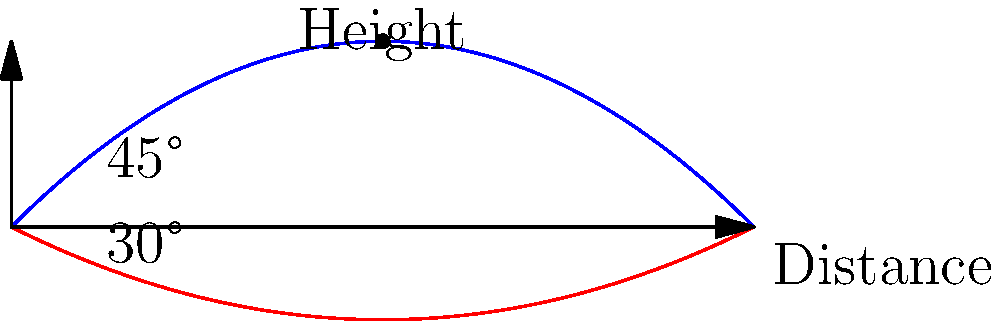As a football coach, you're teaching your players about the optimal angle for a long-distance kick. The graph shows two trajectories: one for a 45° kick (blue) and one for a 30° kick (red). Assuming no air resistance and constant initial velocity, which angle produces the maximum distance, and why? To determine the optimal angle for maximum distance, let's analyze the situation step-by-step:

1) In ideal conditions (no air resistance), the trajectory of a projectile follows a parabolic path.

2) The range (R) of a projectile is given by the formula:
   $$R = \frac{v^2 \sin(2\theta)}{g}$$
   where $v$ is the initial velocity, $\theta$ is the launch angle, and $g$ is the acceleration due to gravity.

3) To maximize R, we need to maximize $\sin(2\theta)$.

4) The maximum value of sine is 1, which occurs when its argument is 90°.

5) So, we want $2\theta = 90°$, which means $\theta = 45°$.

6) This is why the 45° trajectory (blue curve) reaches a further distance than the 30° trajectory (red curve).

7) In real-world conditions with air resistance, the optimal angle is slightly less than 45°, typically around 40-43°, but 45° is the theoretical optimum.
Answer: 45° 